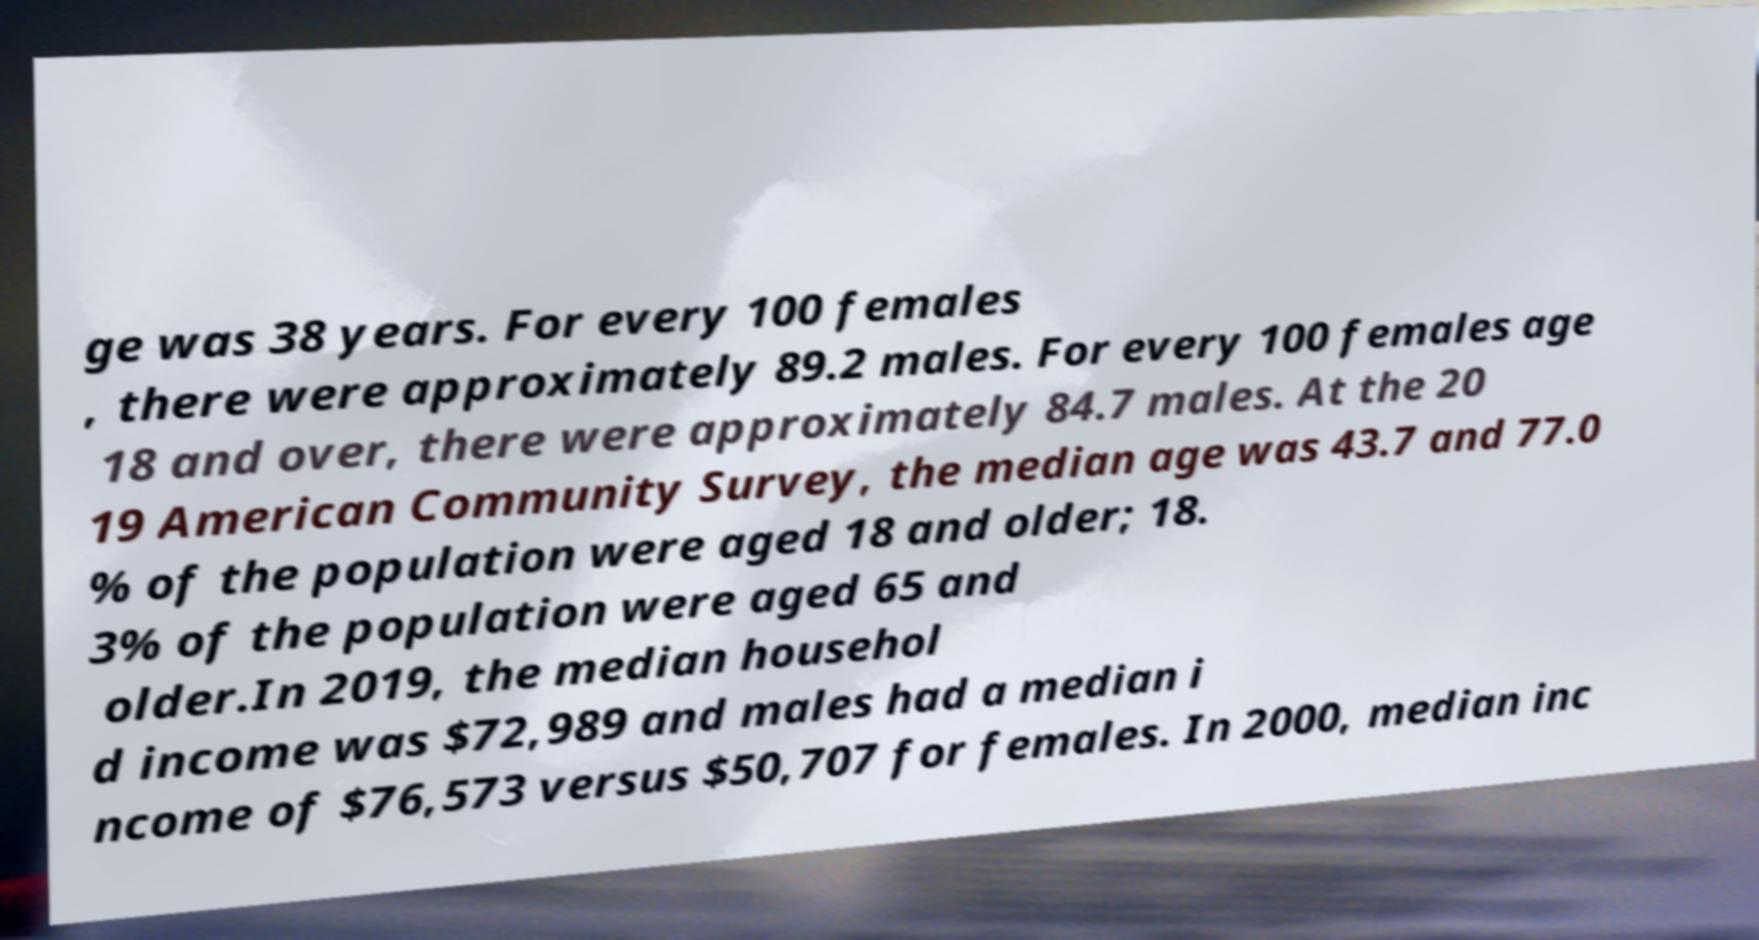Could you extract and type out the text from this image? ge was 38 years. For every 100 females , there were approximately 89.2 males. For every 100 females age 18 and over, there were approximately 84.7 males. At the 20 19 American Community Survey, the median age was 43.7 and 77.0 % of the population were aged 18 and older; 18. 3% of the population were aged 65 and older.In 2019, the median househol d income was $72,989 and males had a median i ncome of $76,573 versus $50,707 for females. In 2000, median inc 